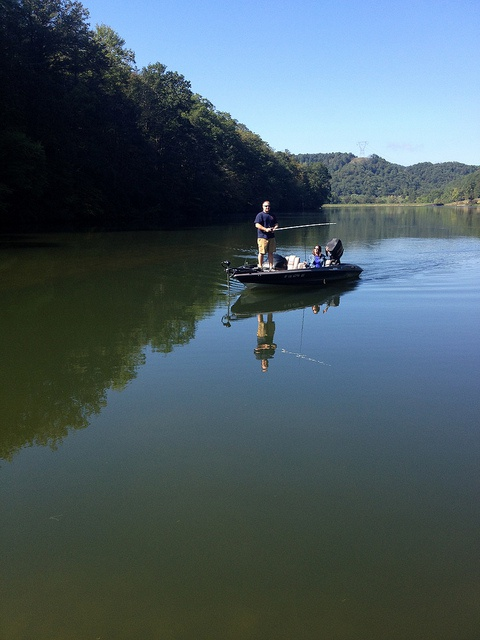Describe the objects in this image and their specific colors. I can see boat in black, gray, darkgray, and navy tones, people in black, gray, navy, and beige tones, and people in black, darkgray, navy, and gray tones in this image. 